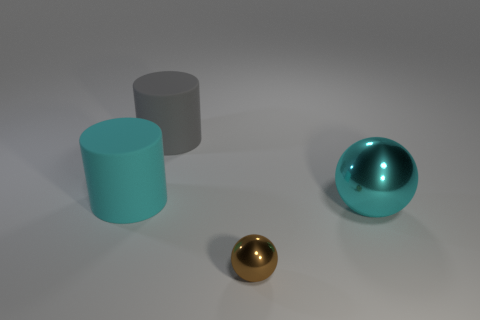Add 1 big cyan metal things. How many objects exist? 5 Subtract all gray cylinders. How many cylinders are left? 1 Subtract all matte objects. Subtract all big cylinders. How many objects are left? 0 Add 4 big cylinders. How many big cylinders are left? 6 Add 2 large cyan rubber objects. How many large cyan rubber objects exist? 3 Subtract 0 gray spheres. How many objects are left? 4 Subtract 1 spheres. How many spheres are left? 1 Subtract all purple spheres. Subtract all green blocks. How many spheres are left? 2 Subtract all blue blocks. How many cyan spheres are left? 1 